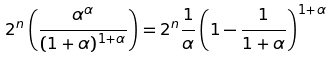<formula> <loc_0><loc_0><loc_500><loc_500>2 ^ { n } \left ( \frac { \alpha ^ { \alpha } } { ( 1 + \alpha ) ^ { 1 + \alpha } } \right ) = 2 ^ { n } \frac { 1 } { \alpha } \left ( 1 - \frac { 1 } { 1 + \alpha } \right ) ^ { 1 + \alpha }</formula> 